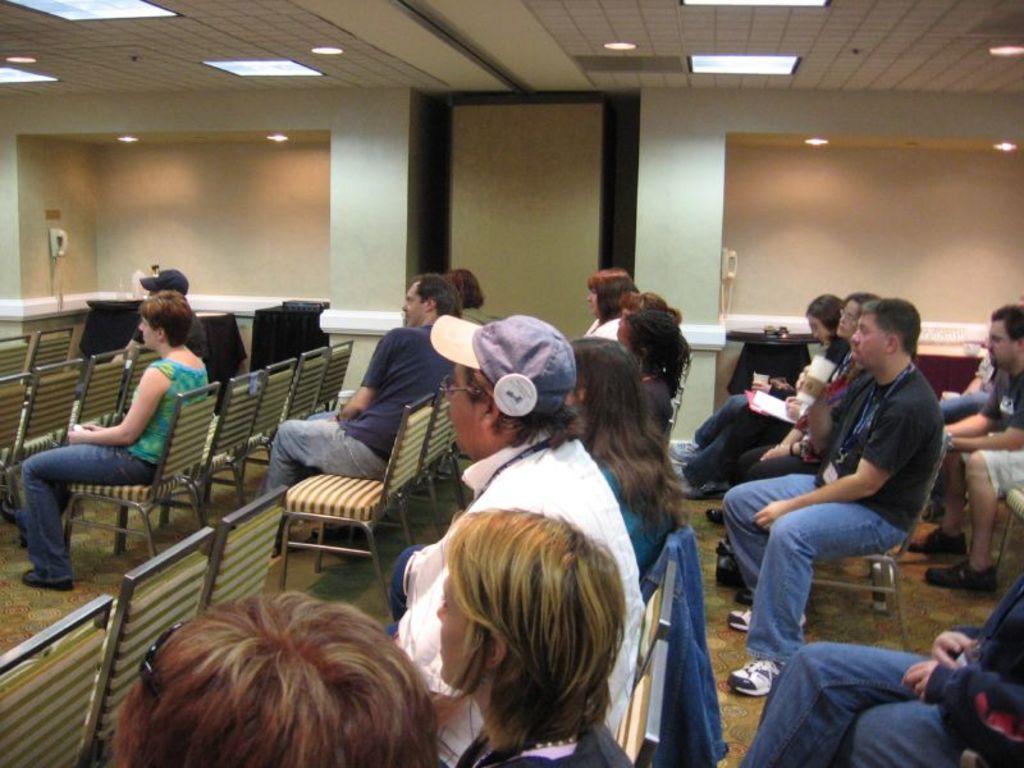Please provide a concise description of this image. in the picture we can see the room with different chairs,here we can see the people sitting on the chair and listening to someone,here we can see lights present on the roof of the wall. 